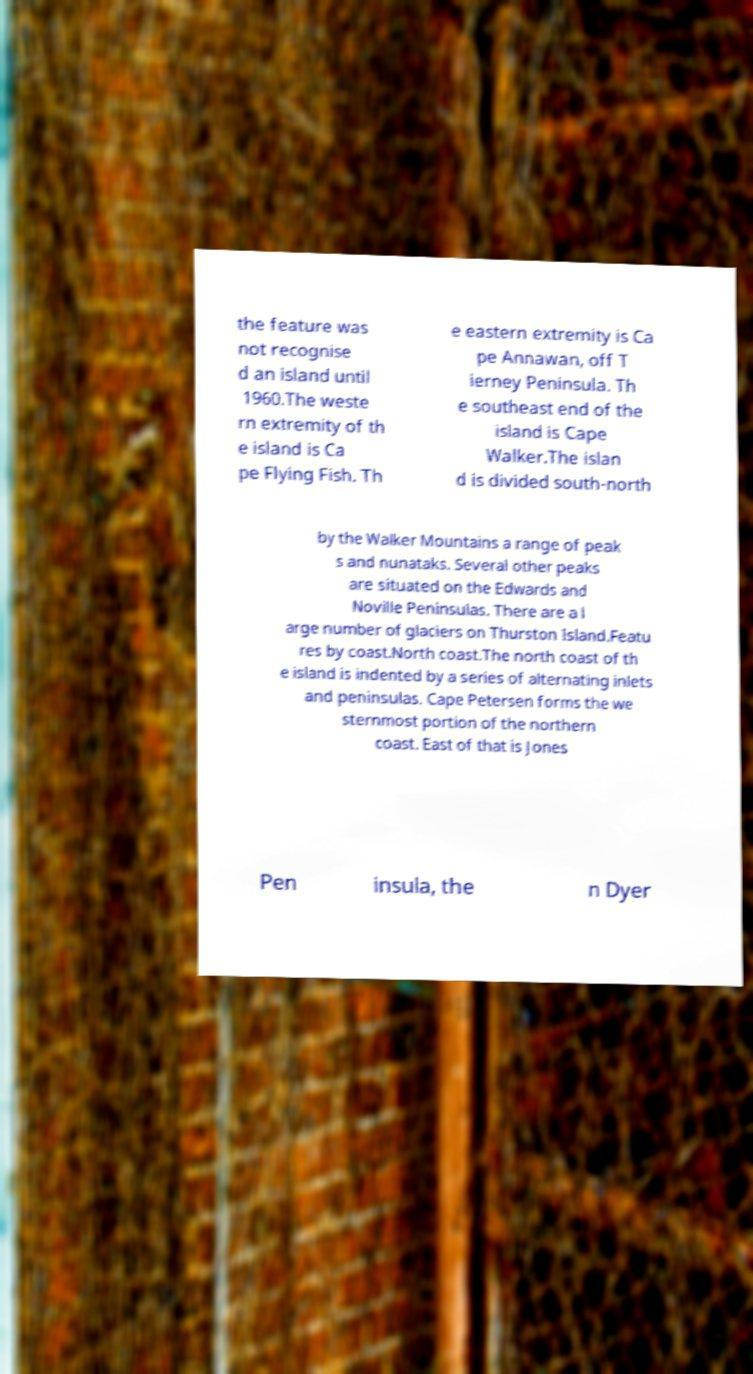Could you extract and type out the text from this image? the feature was not recognise d an island until 1960.The weste rn extremity of th e island is Ca pe Flying Fish. Th e eastern extremity is Ca pe Annawan, off T ierney Peninsula. Th e southeast end of the island is Cape Walker.The islan d is divided south-north by the Walker Mountains a range of peak s and nunataks. Several other peaks are situated on the Edwards and Noville Peninsulas. There are a l arge number of glaciers on Thurston Island.Featu res by coast.North coast.The north coast of th e island is indented by a series of alternating inlets and peninsulas. Cape Petersen forms the we sternmost portion of the northern coast. East of that is Jones Pen insula, the n Dyer 